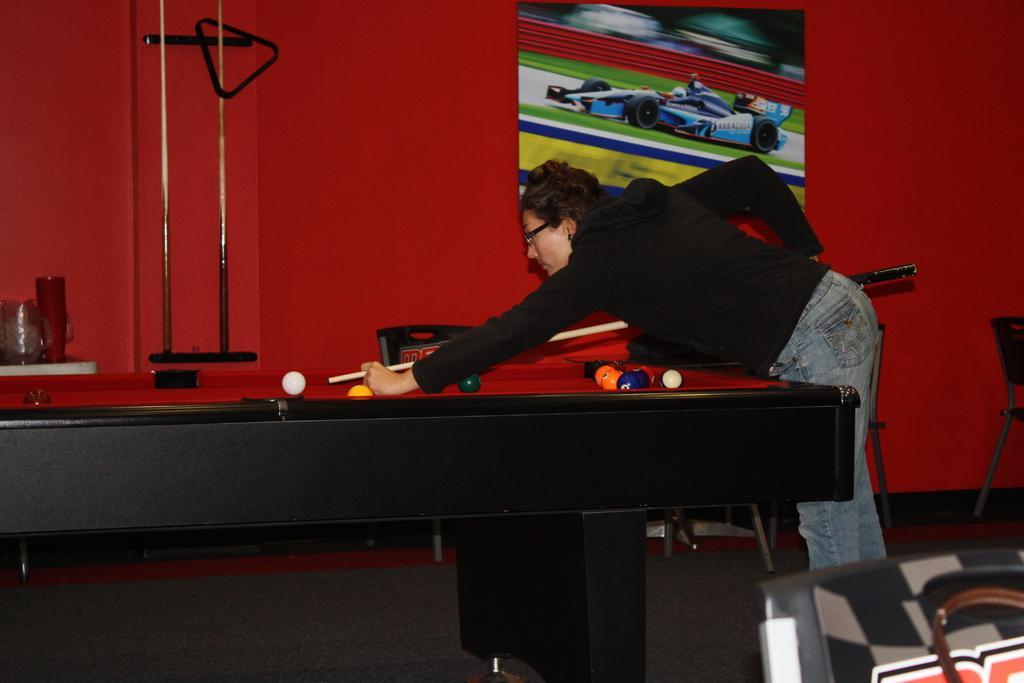Can you describe this image briefly? In the image we can see there is a person who is holding a billard stick and playing billiards on the billiards board and at the back the wall is in red colour. 